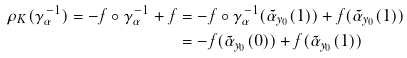Convert formula to latex. <formula><loc_0><loc_0><loc_500><loc_500>\rho _ { K } ( \gamma _ { \alpha } ^ { - 1 } ) = - f \circ \gamma _ { \alpha } ^ { - 1 } + f & = - f \circ \gamma _ { \alpha } ^ { - 1 } ( \tilde { \alpha } _ { y _ { 0 } } ( 1 ) ) + f ( \tilde { \alpha } _ { y _ { 0 } } ( 1 ) ) \\ & = - f ( \tilde { \alpha } _ { y _ { 0 } } ( 0 ) ) + f ( \tilde { \alpha } _ { y _ { 0 } } ( 1 ) )</formula> 